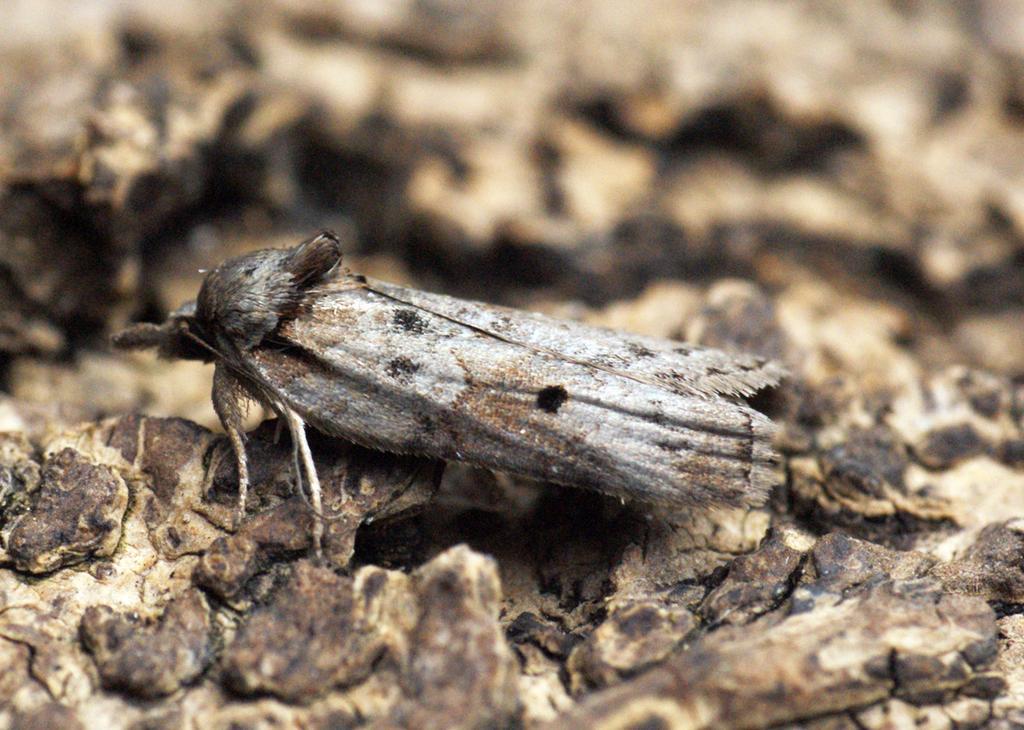Describe this image in one or two sentences. This picture shows a Insect on the tree bark. 